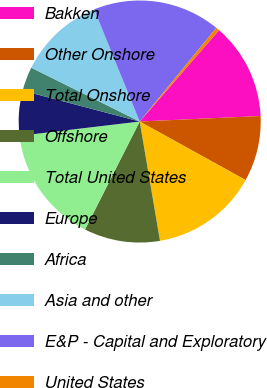Convert chart to OTSL. <chart><loc_0><loc_0><loc_500><loc_500><pie_chart><fcel>Bakken<fcel>Other Onshore<fcel>Total Onshore<fcel>Offshore<fcel>Total United States<fcel>Europe<fcel>Africa<fcel>Asia and other<fcel>E&P - Capital and Exploratory<fcel>United States<nl><fcel>12.9%<fcel>8.76%<fcel>14.28%<fcel>10.14%<fcel>15.66%<fcel>5.99%<fcel>3.23%<fcel>11.52%<fcel>17.05%<fcel>0.47%<nl></chart> 